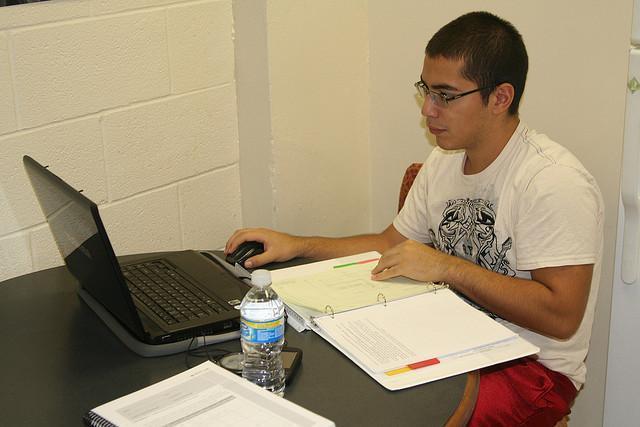How many computers are in this photo?
Give a very brief answer. 1. How many people are looking at laptops?
Give a very brief answer. 1. How many buses are there going to max north?
Give a very brief answer. 0. 